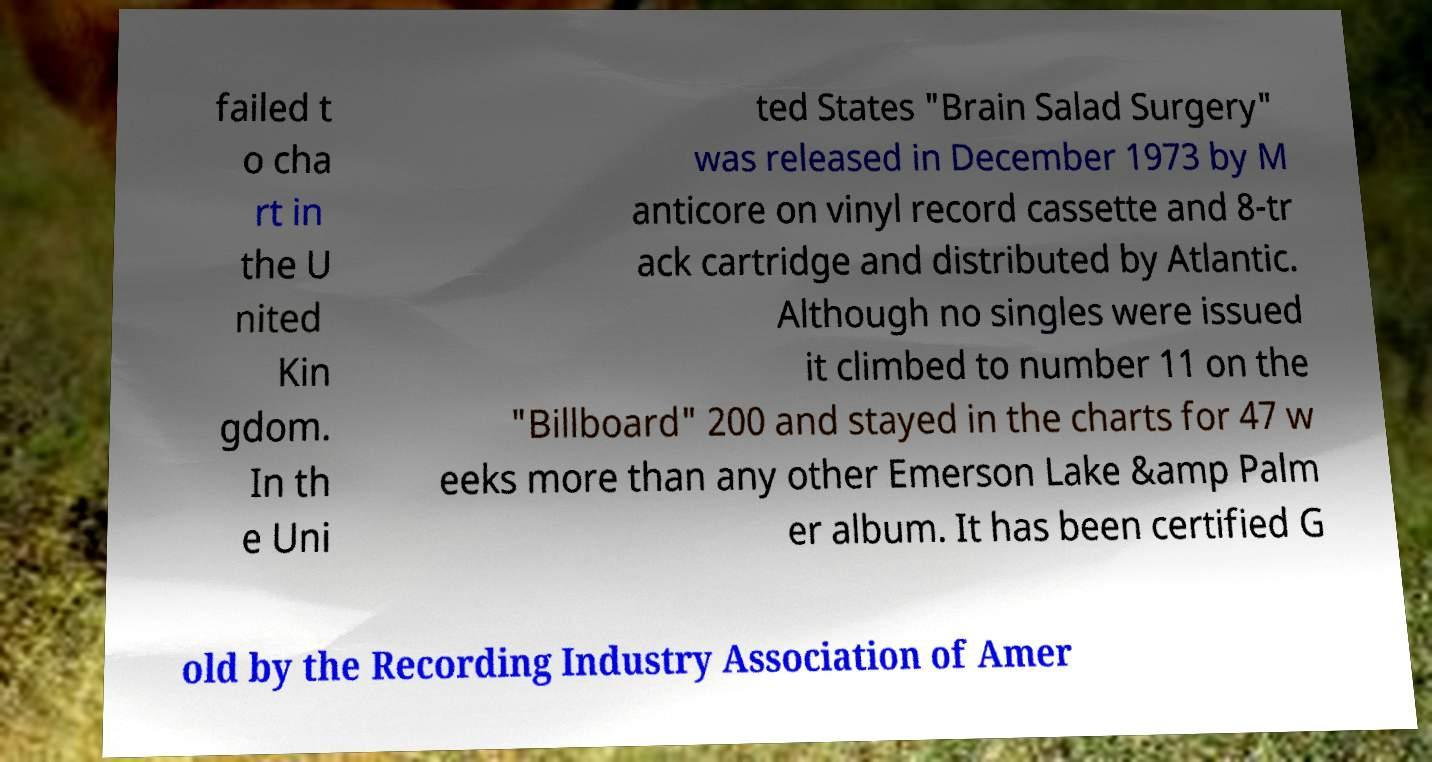Could you extract and type out the text from this image? failed t o cha rt in the U nited Kin gdom. In th e Uni ted States "Brain Salad Surgery" was released in December 1973 by M anticore on vinyl record cassette and 8-tr ack cartridge and distributed by Atlantic. Although no singles were issued it climbed to number 11 on the "Billboard" 200 and stayed in the charts for 47 w eeks more than any other Emerson Lake &amp Palm er album. It has been certified G old by the Recording Industry Association of Amer 